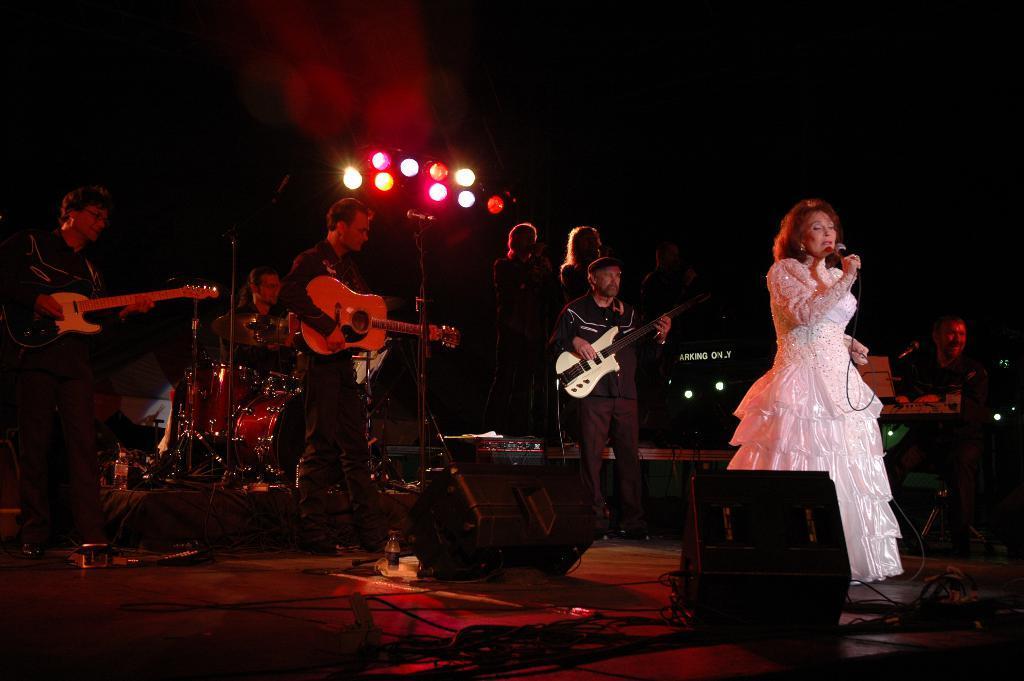Can you describe this image briefly? In this image I see lot of persons on the stage and I see few of them are holding the musical instruments and a woman over here is holding a mic. In the background I see the lights. 